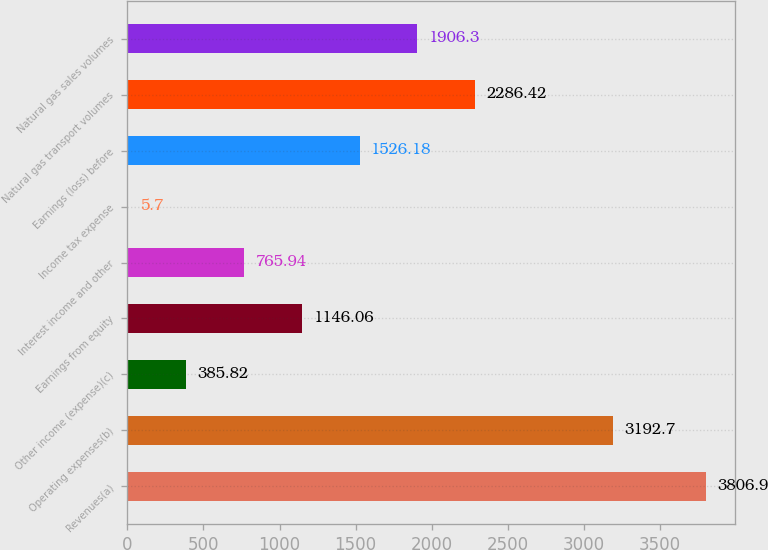Convert chart. <chart><loc_0><loc_0><loc_500><loc_500><bar_chart><fcel>Revenues(a)<fcel>Operating expenses(b)<fcel>Other income (expense)(c)<fcel>Earnings from equity<fcel>Interest income and other<fcel>Income tax expense<fcel>Earnings (loss) before<fcel>Natural gas transport volumes<fcel>Natural gas sales volumes<nl><fcel>3806.9<fcel>3192.7<fcel>385.82<fcel>1146.06<fcel>765.94<fcel>5.7<fcel>1526.18<fcel>2286.42<fcel>1906.3<nl></chart> 